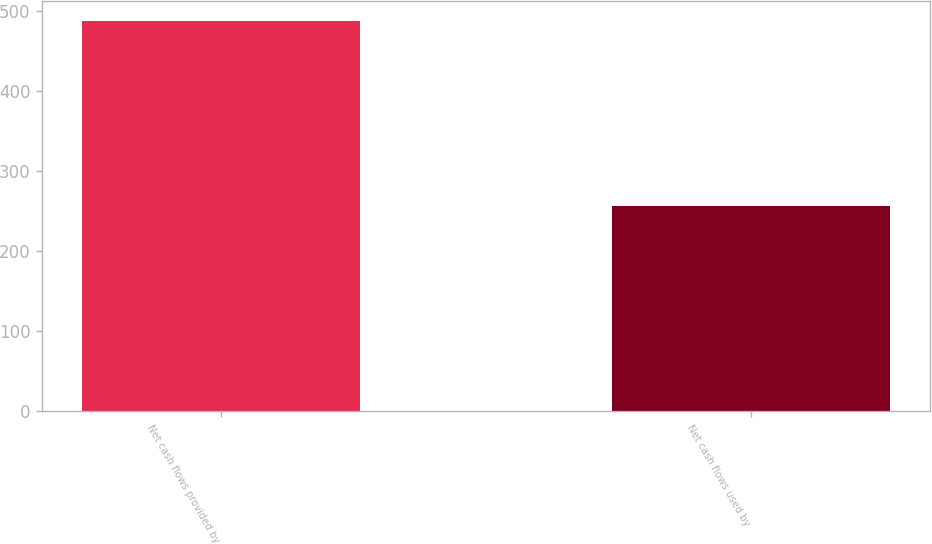Convert chart to OTSL. <chart><loc_0><loc_0><loc_500><loc_500><bar_chart><fcel>Net cash flows provided by<fcel>Net cash flows used by<nl><fcel>487.8<fcel>255.8<nl></chart> 